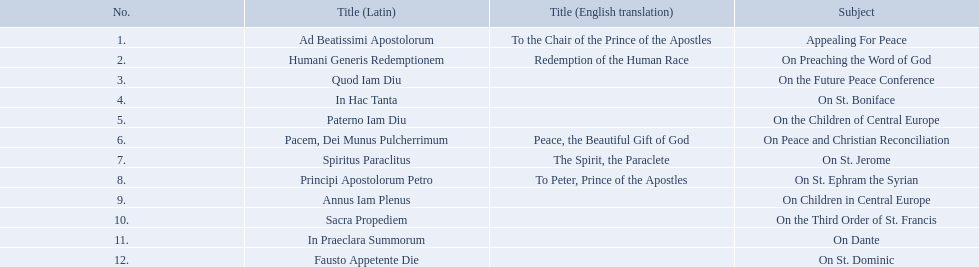What is the dates of the list of encyclicals of pope benedict xv? 1 November 1914, 15 June 1917, 1 December 1918, 14 May 1919, 24 November 1919, 23 May 1920, 15 September 1920, 5 October 1920, 1 December 1920, 6 January 1921, 30 April 1921, 29 June 1921. Of these dates, which subject was on 23 may 1920? On Peace and Christian Reconciliation. 